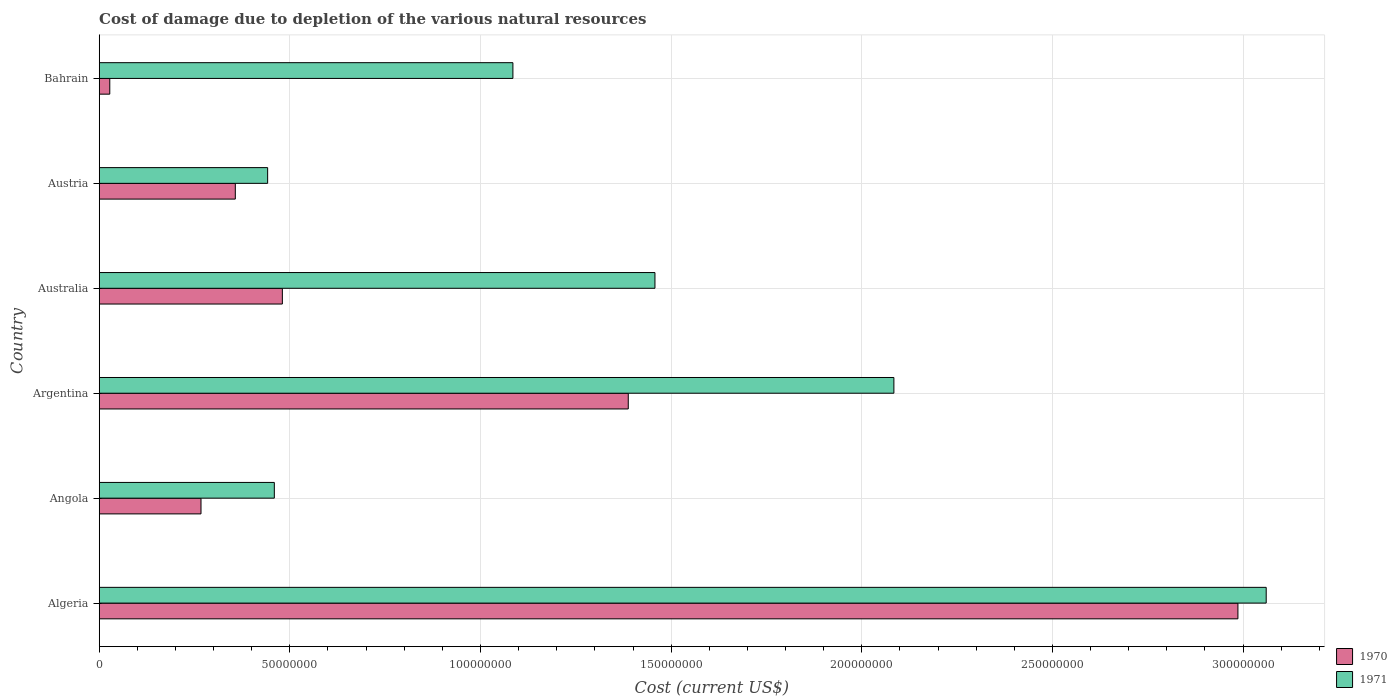How many different coloured bars are there?
Your answer should be compact. 2. How many groups of bars are there?
Your response must be concise. 6. Are the number of bars per tick equal to the number of legend labels?
Ensure brevity in your answer.  Yes. Are the number of bars on each tick of the Y-axis equal?
Your answer should be compact. Yes. What is the label of the 5th group of bars from the top?
Your answer should be very brief. Angola. In how many cases, is the number of bars for a given country not equal to the number of legend labels?
Your answer should be very brief. 0. What is the cost of damage caused due to the depletion of various natural resources in 1970 in Argentina?
Offer a very short reply. 1.39e+08. Across all countries, what is the maximum cost of damage caused due to the depletion of various natural resources in 1970?
Your answer should be compact. 2.99e+08. Across all countries, what is the minimum cost of damage caused due to the depletion of various natural resources in 1971?
Your response must be concise. 4.42e+07. In which country was the cost of damage caused due to the depletion of various natural resources in 1971 maximum?
Keep it short and to the point. Algeria. In which country was the cost of damage caused due to the depletion of various natural resources in 1970 minimum?
Ensure brevity in your answer.  Bahrain. What is the total cost of damage caused due to the depletion of various natural resources in 1970 in the graph?
Ensure brevity in your answer.  5.51e+08. What is the difference between the cost of damage caused due to the depletion of various natural resources in 1971 in Austria and that in Bahrain?
Offer a terse response. -6.43e+07. What is the difference between the cost of damage caused due to the depletion of various natural resources in 1970 in Angola and the cost of damage caused due to the depletion of various natural resources in 1971 in Bahrain?
Provide a succinct answer. -8.18e+07. What is the average cost of damage caused due to the depletion of various natural resources in 1970 per country?
Make the answer very short. 9.18e+07. What is the difference between the cost of damage caused due to the depletion of various natural resources in 1971 and cost of damage caused due to the depletion of various natural resources in 1970 in Bahrain?
Make the answer very short. 1.06e+08. In how many countries, is the cost of damage caused due to the depletion of various natural resources in 1971 greater than 230000000 US$?
Provide a succinct answer. 1. What is the ratio of the cost of damage caused due to the depletion of various natural resources in 1971 in Algeria to that in Angola?
Your answer should be compact. 6.66. Is the cost of damage caused due to the depletion of various natural resources in 1970 in Angola less than that in Australia?
Offer a very short reply. Yes. Is the difference between the cost of damage caused due to the depletion of various natural resources in 1971 in Angola and Argentina greater than the difference between the cost of damage caused due to the depletion of various natural resources in 1970 in Angola and Argentina?
Ensure brevity in your answer.  No. What is the difference between the highest and the second highest cost of damage caused due to the depletion of various natural resources in 1970?
Your answer should be compact. 1.60e+08. What is the difference between the highest and the lowest cost of damage caused due to the depletion of various natural resources in 1971?
Give a very brief answer. 2.62e+08. In how many countries, is the cost of damage caused due to the depletion of various natural resources in 1971 greater than the average cost of damage caused due to the depletion of various natural resources in 1971 taken over all countries?
Your answer should be compact. 3. What does the 2nd bar from the top in Angola represents?
Make the answer very short. 1970. What does the 1st bar from the bottom in Argentina represents?
Your answer should be compact. 1970. How many bars are there?
Give a very brief answer. 12. What is the difference between two consecutive major ticks on the X-axis?
Make the answer very short. 5.00e+07. Does the graph contain any zero values?
Your answer should be compact. No. Does the graph contain grids?
Provide a succinct answer. Yes. Where does the legend appear in the graph?
Offer a terse response. Bottom right. How many legend labels are there?
Provide a succinct answer. 2. How are the legend labels stacked?
Offer a very short reply. Vertical. What is the title of the graph?
Offer a terse response. Cost of damage due to depletion of the various natural resources. Does "1993" appear as one of the legend labels in the graph?
Provide a short and direct response. No. What is the label or title of the X-axis?
Your response must be concise. Cost (current US$). What is the Cost (current US$) of 1970 in Algeria?
Ensure brevity in your answer.  2.99e+08. What is the Cost (current US$) of 1971 in Algeria?
Provide a short and direct response. 3.06e+08. What is the Cost (current US$) of 1970 in Angola?
Give a very brief answer. 2.67e+07. What is the Cost (current US$) of 1971 in Angola?
Offer a terse response. 4.59e+07. What is the Cost (current US$) in 1970 in Argentina?
Your answer should be compact. 1.39e+08. What is the Cost (current US$) of 1971 in Argentina?
Your response must be concise. 2.08e+08. What is the Cost (current US$) of 1970 in Australia?
Offer a very short reply. 4.80e+07. What is the Cost (current US$) in 1971 in Australia?
Keep it short and to the point. 1.46e+08. What is the Cost (current US$) in 1970 in Austria?
Keep it short and to the point. 3.57e+07. What is the Cost (current US$) in 1971 in Austria?
Provide a short and direct response. 4.42e+07. What is the Cost (current US$) in 1970 in Bahrain?
Offer a terse response. 2.77e+06. What is the Cost (current US$) of 1971 in Bahrain?
Keep it short and to the point. 1.09e+08. Across all countries, what is the maximum Cost (current US$) in 1970?
Provide a succinct answer. 2.99e+08. Across all countries, what is the maximum Cost (current US$) in 1971?
Give a very brief answer. 3.06e+08. Across all countries, what is the minimum Cost (current US$) in 1970?
Offer a very short reply. 2.77e+06. Across all countries, what is the minimum Cost (current US$) in 1971?
Your answer should be compact. 4.42e+07. What is the total Cost (current US$) of 1970 in the graph?
Your response must be concise. 5.51e+08. What is the total Cost (current US$) in 1971 in the graph?
Keep it short and to the point. 8.59e+08. What is the difference between the Cost (current US$) in 1970 in Algeria and that in Angola?
Your answer should be very brief. 2.72e+08. What is the difference between the Cost (current US$) in 1971 in Algeria and that in Angola?
Keep it short and to the point. 2.60e+08. What is the difference between the Cost (current US$) in 1970 in Algeria and that in Argentina?
Make the answer very short. 1.60e+08. What is the difference between the Cost (current US$) in 1971 in Algeria and that in Argentina?
Offer a very short reply. 9.77e+07. What is the difference between the Cost (current US$) in 1970 in Algeria and that in Australia?
Make the answer very short. 2.51e+08. What is the difference between the Cost (current US$) of 1971 in Algeria and that in Australia?
Offer a terse response. 1.60e+08. What is the difference between the Cost (current US$) in 1970 in Algeria and that in Austria?
Provide a short and direct response. 2.63e+08. What is the difference between the Cost (current US$) of 1971 in Algeria and that in Austria?
Your response must be concise. 2.62e+08. What is the difference between the Cost (current US$) of 1970 in Algeria and that in Bahrain?
Make the answer very short. 2.96e+08. What is the difference between the Cost (current US$) in 1971 in Algeria and that in Bahrain?
Make the answer very short. 1.98e+08. What is the difference between the Cost (current US$) of 1970 in Angola and that in Argentina?
Your answer should be very brief. -1.12e+08. What is the difference between the Cost (current US$) of 1971 in Angola and that in Argentina?
Provide a succinct answer. -1.62e+08. What is the difference between the Cost (current US$) of 1970 in Angola and that in Australia?
Your answer should be very brief. -2.13e+07. What is the difference between the Cost (current US$) of 1971 in Angola and that in Australia?
Keep it short and to the point. -9.98e+07. What is the difference between the Cost (current US$) in 1970 in Angola and that in Austria?
Provide a succinct answer. -9.00e+06. What is the difference between the Cost (current US$) of 1971 in Angola and that in Austria?
Give a very brief answer. 1.76e+06. What is the difference between the Cost (current US$) in 1970 in Angola and that in Bahrain?
Your answer should be compact. 2.39e+07. What is the difference between the Cost (current US$) of 1971 in Angola and that in Bahrain?
Provide a succinct answer. -6.26e+07. What is the difference between the Cost (current US$) in 1970 in Argentina and that in Australia?
Your response must be concise. 9.07e+07. What is the difference between the Cost (current US$) of 1971 in Argentina and that in Australia?
Your response must be concise. 6.27e+07. What is the difference between the Cost (current US$) of 1970 in Argentina and that in Austria?
Offer a very short reply. 1.03e+08. What is the difference between the Cost (current US$) of 1971 in Argentina and that in Austria?
Offer a very short reply. 1.64e+08. What is the difference between the Cost (current US$) in 1970 in Argentina and that in Bahrain?
Provide a short and direct response. 1.36e+08. What is the difference between the Cost (current US$) in 1971 in Argentina and that in Bahrain?
Offer a terse response. 9.99e+07. What is the difference between the Cost (current US$) of 1970 in Australia and that in Austria?
Provide a succinct answer. 1.23e+07. What is the difference between the Cost (current US$) of 1971 in Australia and that in Austria?
Provide a succinct answer. 1.02e+08. What is the difference between the Cost (current US$) in 1970 in Australia and that in Bahrain?
Offer a very short reply. 4.53e+07. What is the difference between the Cost (current US$) in 1971 in Australia and that in Bahrain?
Provide a short and direct response. 3.73e+07. What is the difference between the Cost (current US$) of 1970 in Austria and that in Bahrain?
Provide a succinct answer. 3.29e+07. What is the difference between the Cost (current US$) of 1971 in Austria and that in Bahrain?
Offer a very short reply. -6.43e+07. What is the difference between the Cost (current US$) in 1970 in Algeria and the Cost (current US$) in 1971 in Angola?
Make the answer very short. 2.53e+08. What is the difference between the Cost (current US$) in 1970 in Algeria and the Cost (current US$) in 1971 in Argentina?
Your answer should be very brief. 9.02e+07. What is the difference between the Cost (current US$) in 1970 in Algeria and the Cost (current US$) in 1971 in Australia?
Give a very brief answer. 1.53e+08. What is the difference between the Cost (current US$) of 1970 in Algeria and the Cost (current US$) of 1971 in Austria?
Offer a terse response. 2.54e+08. What is the difference between the Cost (current US$) of 1970 in Algeria and the Cost (current US$) of 1971 in Bahrain?
Provide a short and direct response. 1.90e+08. What is the difference between the Cost (current US$) of 1970 in Angola and the Cost (current US$) of 1971 in Argentina?
Your response must be concise. -1.82e+08. What is the difference between the Cost (current US$) in 1970 in Angola and the Cost (current US$) in 1971 in Australia?
Ensure brevity in your answer.  -1.19e+08. What is the difference between the Cost (current US$) in 1970 in Angola and the Cost (current US$) in 1971 in Austria?
Offer a terse response. -1.75e+07. What is the difference between the Cost (current US$) in 1970 in Angola and the Cost (current US$) in 1971 in Bahrain?
Keep it short and to the point. -8.18e+07. What is the difference between the Cost (current US$) in 1970 in Argentina and the Cost (current US$) in 1971 in Australia?
Your response must be concise. -7.00e+06. What is the difference between the Cost (current US$) in 1970 in Argentina and the Cost (current US$) in 1971 in Austria?
Ensure brevity in your answer.  9.46e+07. What is the difference between the Cost (current US$) in 1970 in Argentina and the Cost (current US$) in 1971 in Bahrain?
Offer a very short reply. 3.03e+07. What is the difference between the Cost (current US$) in 1970 in Australia and the Cost (current US$) in 1971 in Austria?
Give a very brief answer. 3.86e+06. What is the difference between the Cost (current US$) of 1970 in Australia and the Cost (current US$) of 1971 in Bahrain?
Your response must be concise. -6.05e+07. What is the difference between the Cost (current US$) in 1970 in Austria and the Cost (current US$) in 1971 in Bahrain?
Your answer should be very brief. -7.28e+07. What is the average Cost (current US$) in 1970 per country?
Make the answer very short. 9.18e+07. What is the average Cost (current US$) of 1971 per country?
Provide a short and direct response. 1.43e+08. What is the difference between the Cost (current US$) of 1970 and Cost (current US$) of 1971 in Algeria?
Your response must be concise. -7.42e+06. What is the difference between the Cost (current US$) of 1970 and Cost (current US$) of 1971 in Angola?
Offer a terse response. -1.92e+07. What is the difference between the Cost (current US$) of 1970 and Cost (current US$) of 1971 in Argentina?
Make the answer very short. -6.97e+07. What is the difference between the Cost (current US$) in 1970 and Cost (current US$) in 1971 in Australia?
Your answer should be compact. -9.77e+07. What is the difference between the Cost (current US$) of 1970 and Cost (current US$) of 1971 in Austria?
Your response must be concise. -8.48e+06. What is the difference between the Cost (current US$) of 1970 and Cost (current US$) of 1971 in Bahrain?
Your response must be concise. -1.06e+08. What is the ratio of the Cost (current US$) in 1970 in Algeria to that in Angola?
Your response must be concise. 11.19. What is the ratio of the Cost (current US$) in 1971 in Algeria to that in Angola?
Provide a short and direct response. 6.66. What is the ratio of the Cost (current US$) in 1970 in Algeria to that in Argentina?
Provide a succinct answer. 2.15. What is the ratio of the Cost (current US$) in 1971 in Algeria to that in Argentina?
Your answer should be very brief. 1.47. What is the ratio of the Cost (current US$) in 1970 in Algeria to that in Australia?
Your answer should be compact. 6.22. What is the ratio of the Cost (current US$) in 1971 in Algeria to that in Australia?
Your answer should be compact. 2.1. What is the ratio of the Cost (current US$) in 1970 in Algeria to that in Austria?
Provide a short and direct response. 8.37. What is the ratio of the Cost (current US$) in 1971 in Algeria to that in Austria?
Keep it short and to the point. 6.93. What is the ratio of the Cost (current US$) of 1970 in Algeria to that in Bahrain?
Make the answer very short. 107.82. What is the ratio of the Cost (current US$) in 1971 in Algeria to that in Bahrain?
Your answer should be very brief. 2.82. What is the ratio of the Cost (current US$) in 1970 in Angola to that in Argentina?
Your answer should be very brief. 0.19. What is the ratio of the Cost (current US$) in 1971 in Angola to that in Argentina?
Make the answer very short. 0.22. What is the ratio of the Cost (current US$) in 1970 in Angola to that in Australia?
Give a very brief answer. 0.56. What is the ratio of the Cost (current US$) of 1971 in Angola to that in Australia?
Ensure brevity in your answer.  0.32. What is the ratio of the Cost (current US$) in 1970 in Angola to that in Austria?
Offer a terse response. 0.75. What is the ratio of the Cost (current US$) in 1971 in Angola to that in Austria?
Offer a terse response. 1.04. What is the ratio of the Cost (current US$) in 1970 in Angola to that in Bahrain?
Give a very brief answer. 9.64. What is the ratio of the Cost (current US$) of 1971 in Angola to that in Bahrain?
Your answer should be compact. 0.42. What is the ratio of the Cost (current US$) in 1970 in Argentina to that in Australia?
Ensure brevity in your answer.  2.89. What is the ratio of the Cost (current US$) in 1971 in Argentina to that in Australia?
Provide a succinct answer. 1.43. What is the ratio of the Cost (current US$) in 1970 in Argentina to that in Austria?
Provide a succinct answer. 3.89. What is the ratio of the Cost (current US$) of 1971 in Argentina to that in Austria?
Your response must be concise. 4.72. What is the ratio of the Cost (current US$) of 1970 in Argentina to that in Bahrain?
Offer a terse response. 50.09. What is the ratio of the Cost (current US$) in 1971 in Argentina to that in Bahrain?
Offer a very short reply. 1.92. What is the ratio of the Cost (current US$) of 1970 in Australia to that in Austria?
Provide a succinct answer. 1.35. What is the ratio of the Cost (current US$) in 1971 in Australia to that in Austria?
Your answer should be very brief. 3.3. What is the ratio of the Cost (current US$) of 1970 in Australia to that in Bahrain?
Your answer should be very brief. 17.34. What is the ratio of the Cost (current US$) of 1971 in Australia to that in Bahrain?
Ensure brevity in your answer.  1.34. What is the ratio of the Cost (current US$) of 1970 in Austria to that in Bahrain?
Provide a succinct answer. 12.89. What is the ratio of the Cost (current US$) in 1971 in Austria to that in Bahrain?
Ensure brevity in your answer.  0.41. What is the difference between the highest and the second highest Cost (current US$) of 1970?
Keep it short and to the point. 1.60e+08. What is the difference between the highest and the second highest Cost (current US$) in 1971?
Your answer should be compact. 9.77e+07. What is the difference between the highest and the lowest Cost (current US$) in 1970?
Keep it short and to the point. 2.96e+08. What is the difference between the highest and the lowest Cost (current US$) of 1971?
Offer a terse response. 2.62e+08. 